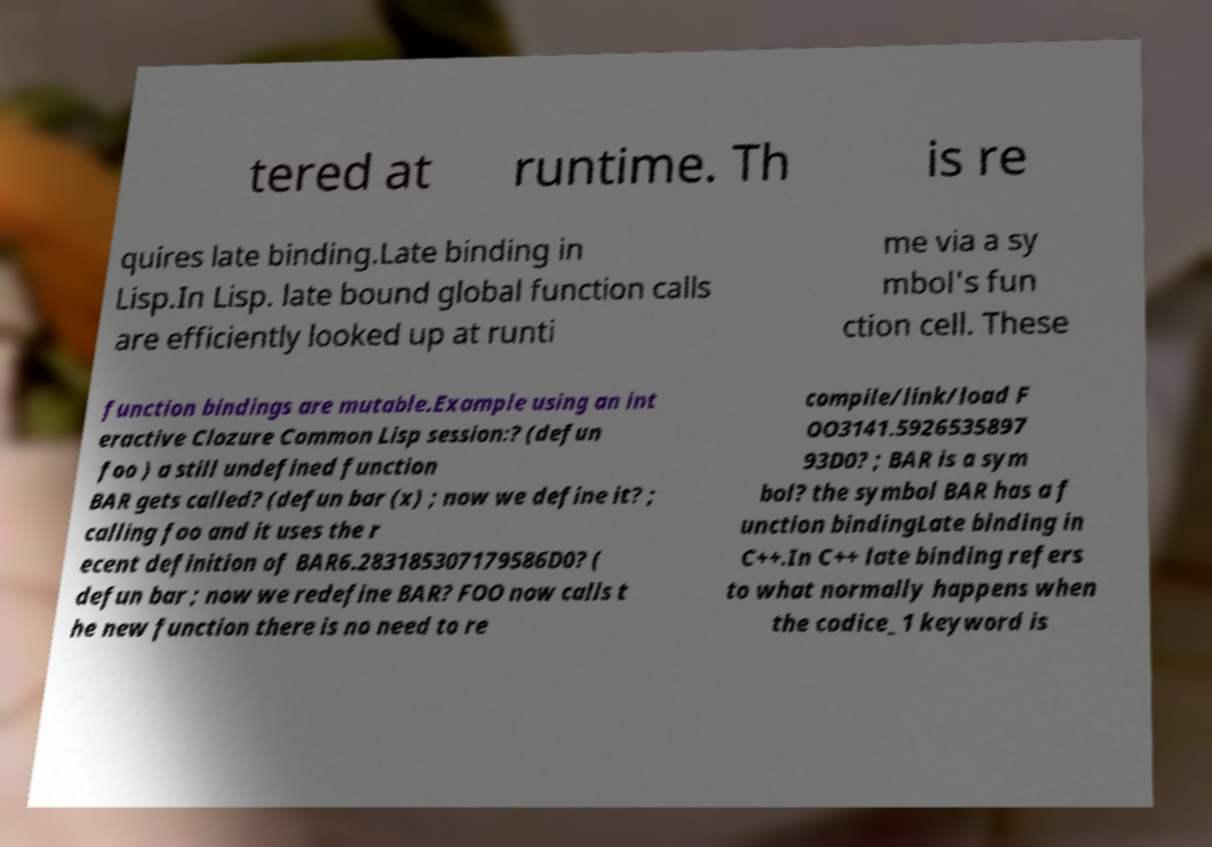Could you assist in decoding the text presented in this image and type it out clearly? tered at runtime. Th is re quires late binding.Late binding in Lisp.In Lisp. late bound global function calls are efficiently looked up at runti me via a sy mbol's fun ction cell. These function bindings are mutable.Example using an int eractive Clozure Common Lisp session:? (defun foo ) a still undefined function BAR gets called? (defun bar (x) ; now we define it? ; calling foo and it uses the r ecent definition of BAR6.283185307179586D0? ( defun bar ; now we redefine BAR? FOO now calls t he new function there is no need to re compile/link/load F OO3141.5926535897 93D0? ; BAR is a sym bol? the symbol BAR has a f unction bindingLate binding in C++.In C++ late binding refers to what normally happens when the codice_1 keyword is 